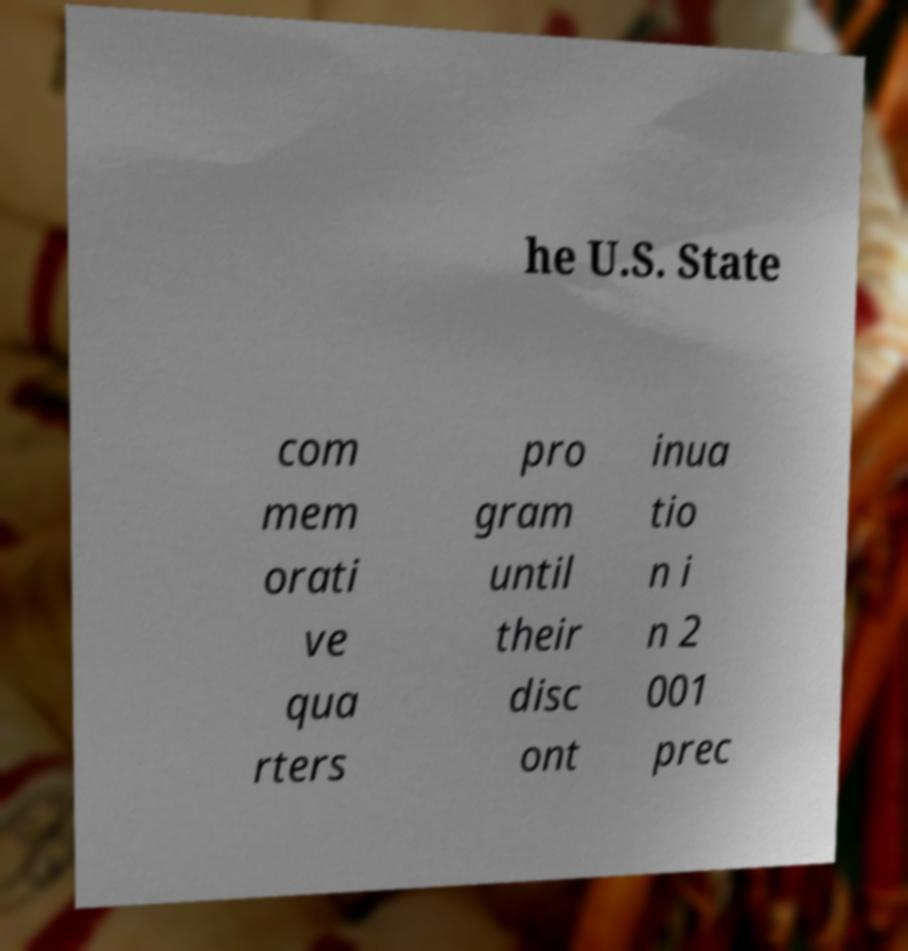Can you read and provide the text displayed in the image?This photo seems to have some interesting text. Can you extract and type it out for me? he U.S. State com mem orati ve qua rters pro gram until their disc ont inua tio n i n 2 001 prec 